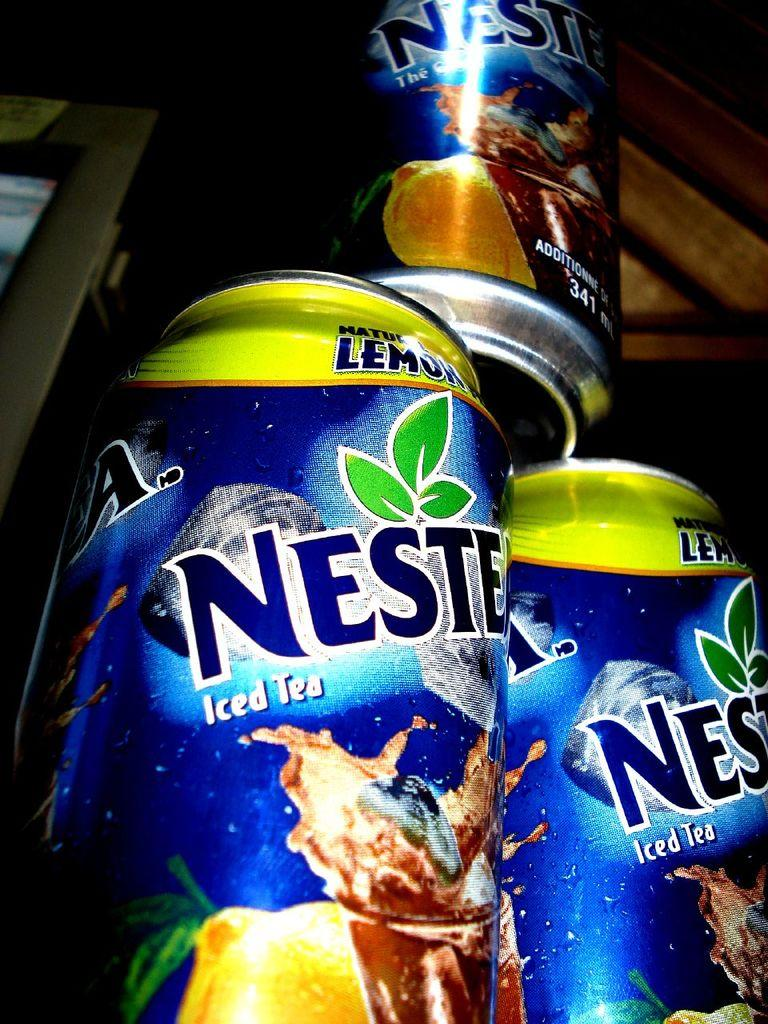Provide a one-sentence caption for the provided image. The blue can of iced tea contains 341 ml of the beverage. 